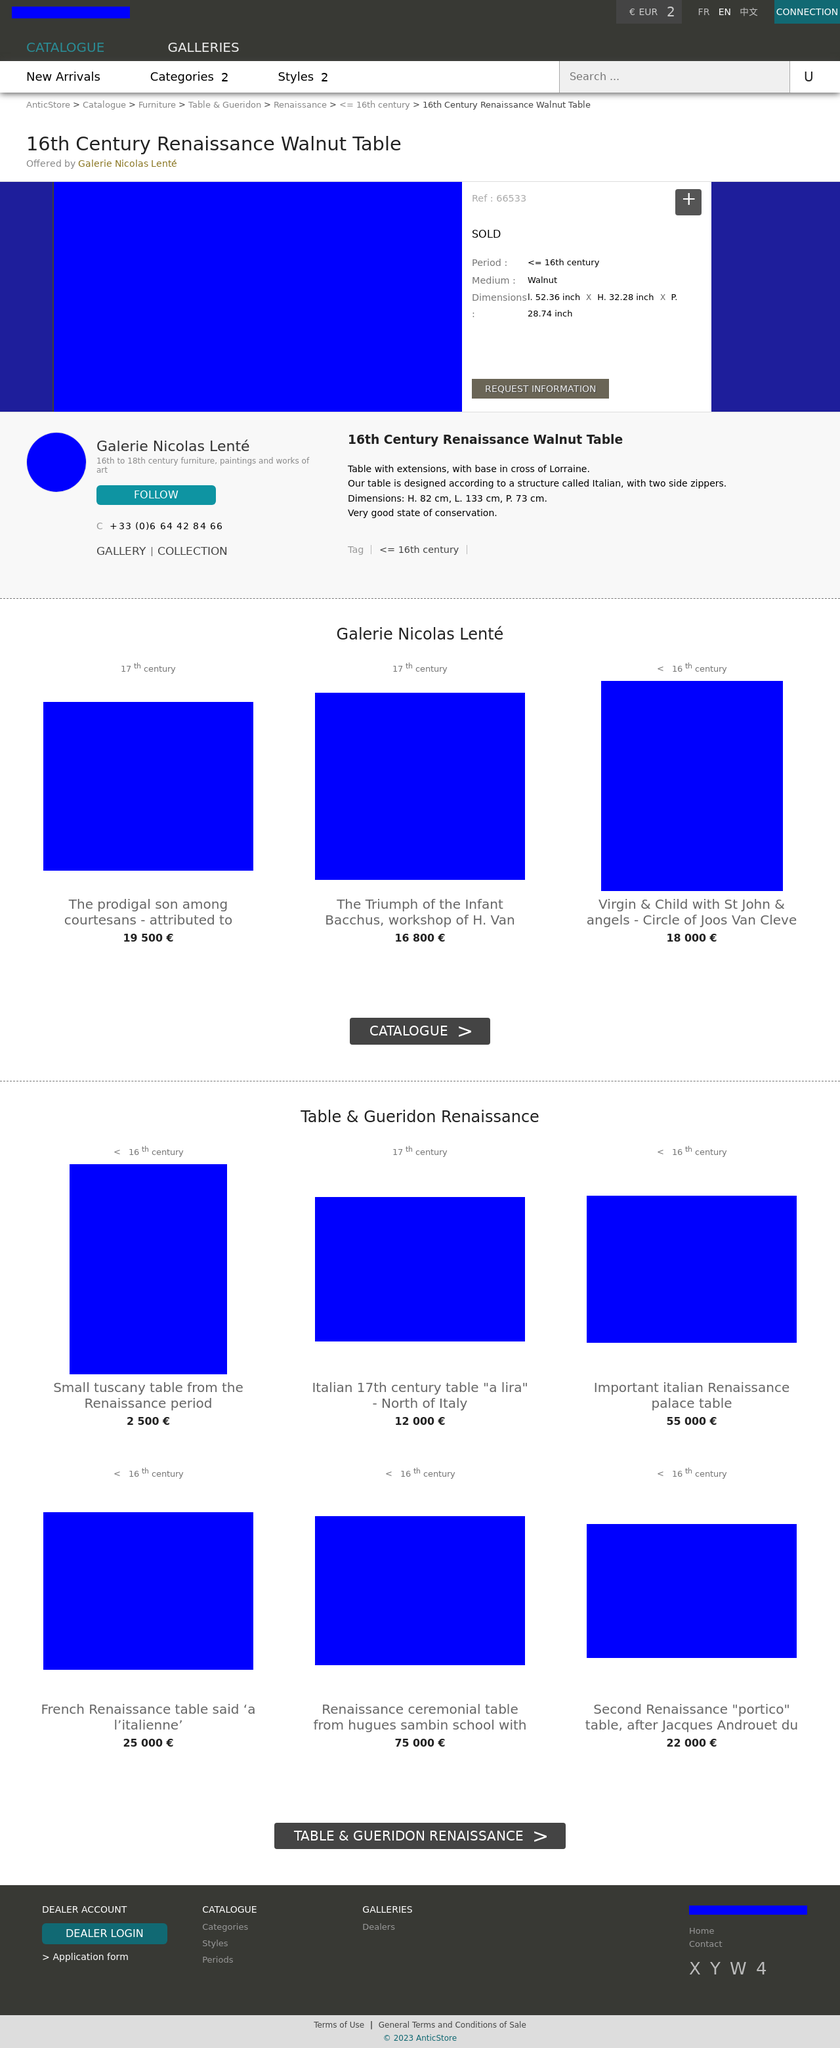Could you guide me through the process of developing this website with HTML? Certainly! When creating a website similar to the one presented in the image, you'll want to start by structuring your HTML document with the proper doctype, html, head, and body tags. From there, you can create a header with navigation, use sections to outline your main content, such as the gallery of items offered, and ensure you have footer information with proper contact links. Use CSS for styling elements to match the visual aesthetic of the design shown in the image. 